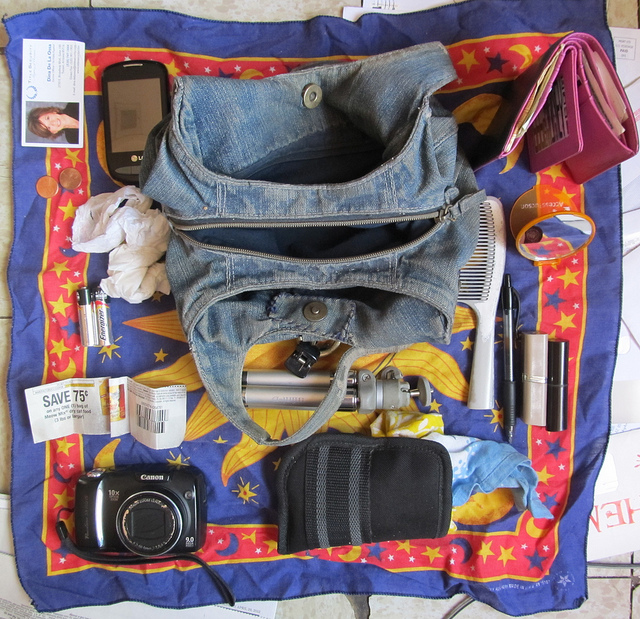Identify the text displayed in this image. SAVE 75 Canon 